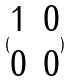<formula> <loc_0><loc_0><loc_500><loc_500>( \begin{matrix} 1 & 0 \\ 0 & 0 \end{matrix} )</formula> 